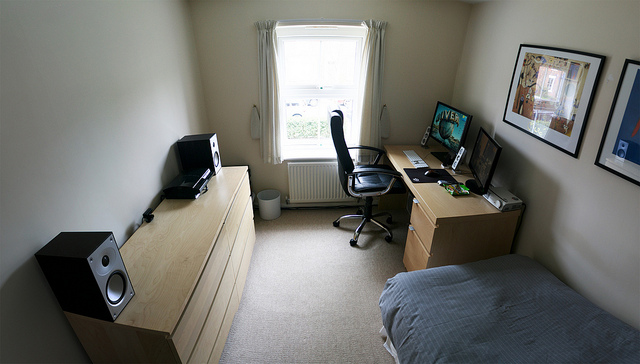Please extract the text content from this image. CIVER 